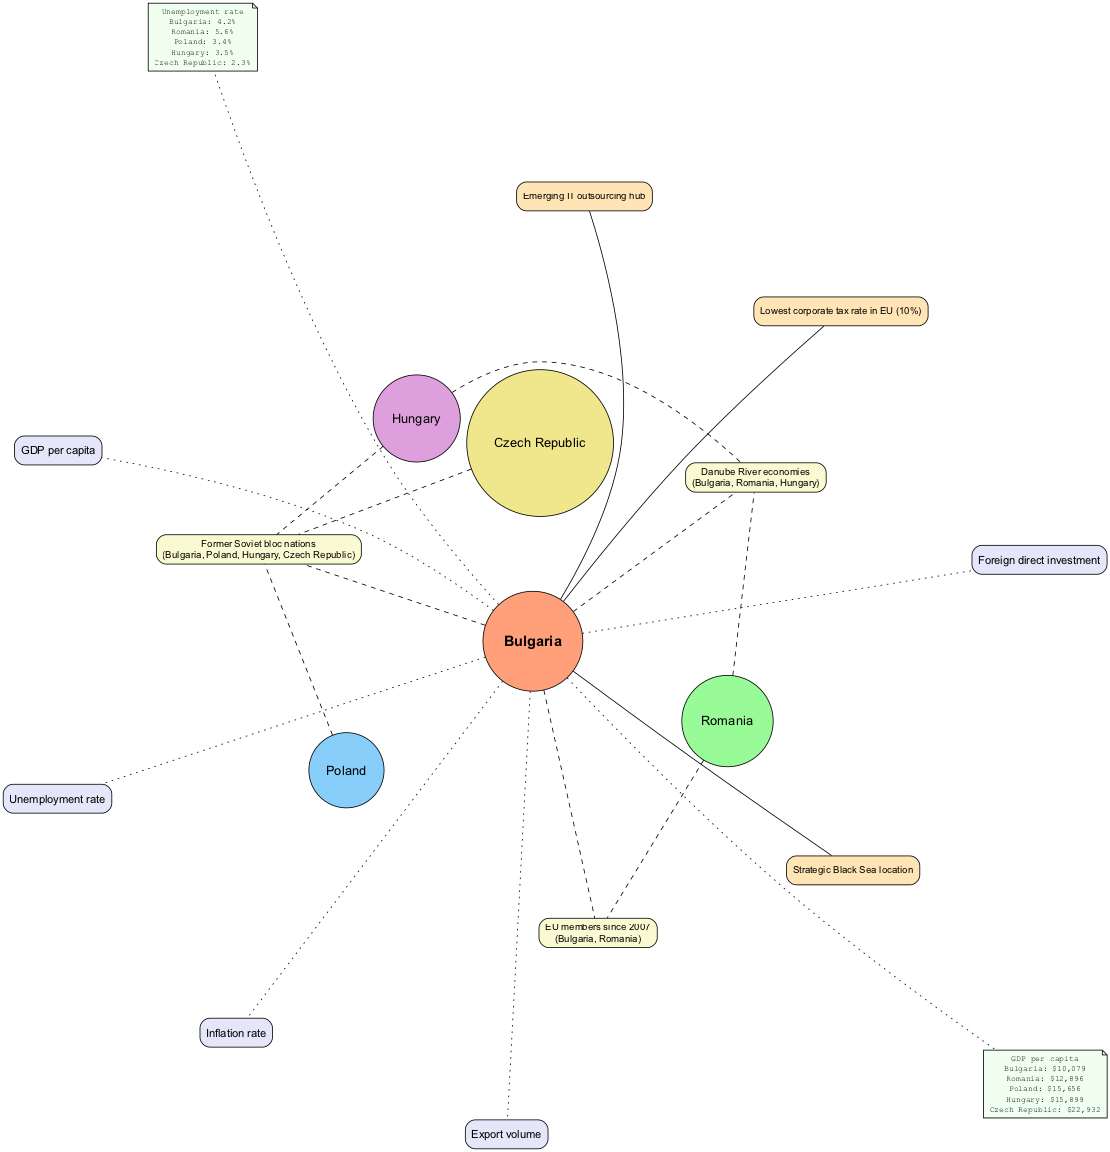What is Bulgaria's GDP per capita? The diagram provides the specific financial indicator for Bulgaria's GDP per capita, which is directly linked to the central circle labeled "Bulgaria". The value stated next to it is "$10,079".
Answer: $10,079 Which country has the lowest unemployment rate? By examining the unemployment rates connected to each country within the diagram, the Czech Republic has the lowest rate indicated at "2.3%".
Answer: Czech Republic How many countries are represented in the overlapping circles? The diagram includes four countries that form the overlapping circles with Bulgaria, which are Romania, Poland, Hungary, and the Czech Republic. Counting these circles, we find a total of four countries.
Answer: 4 What unique trait does Bulgaria possess related to taxation? Among the unique traits listed for Bulgaria, one specifies that it has the "Lowest corporate tax rate in EU (10%)". This is an explicit characteristic that contributes to Bulgaria's economic profile.
Answer: Lowest corporate tax rate in EU (10%) Do Bulgaria and Romania share a common trait? The diagram indicates a shared characteristic between Bulgaria and Romania, which is that they are both "EU members since 2007". This connection highlights a significant political and economic alignment.
Answer: EU members since 2007 What is the inflation rate for Bulgaria? The inflation rate directly associated with Bulgaria is not specified in the data provided; however, if present in the diagram, it would be located in the economic indicators section related to Bulgaria. Without explicit information, we cannot determine this value.
Answer: Not specified Which country has the highest GDP per capita? Analyzing the GDP per capita data points for all countries in the diagram, the Czech Republic shows the highest value at "$22,932". This indicates its relatively stronger economy compared to the others listed.
Answer: Czech Republic What economic indicators are compared for Bulgaria? The diagram lists a total of five economic indicators directly associated with Bulgaria, including GDP per capita, Unemployment rate, Foreign direct investment, Inflation rate, and Export volume. Each indicator plays a role in the overall economic comparison presented.
Answer: GDP per capita, Unemployment rate, Foreign direct investment, Inflation rate, Export volume Which countries are identified as Danube River economies? The diagram highlights a shared characteristic among Bulgaria, Romania, and Hungary, indicating that these three have economies associated with the Danube River. This trait emphasizes their geographical and economic relationship.
Answer: Bulgaria, Romania, Hungary 